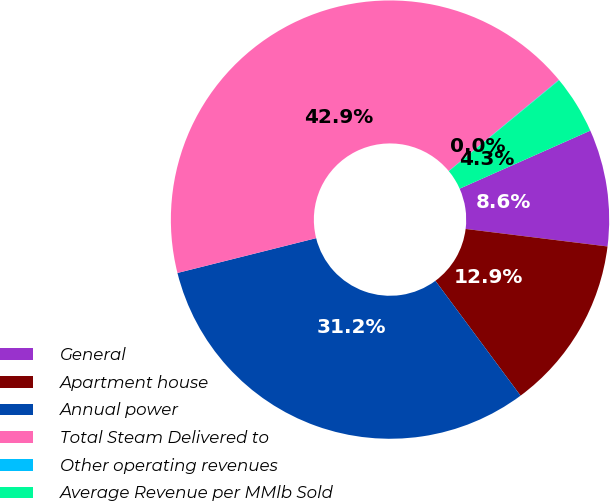<chart> <loc_0><loc_0><loc_500><loc_500><pie_chart><fcel>General<fcel>Apartment house<fcel>Annual power<fcel>Total Steam Delivered to<fcel>Other operating revenues<fcel>Average Revenue per MMlb Sold<nl><fcel>8.61%<fcel>12.89%<fcel>31.24%<fcel>42.91%<fcel>0.03%<fcel>4.32%<nl></chart> 